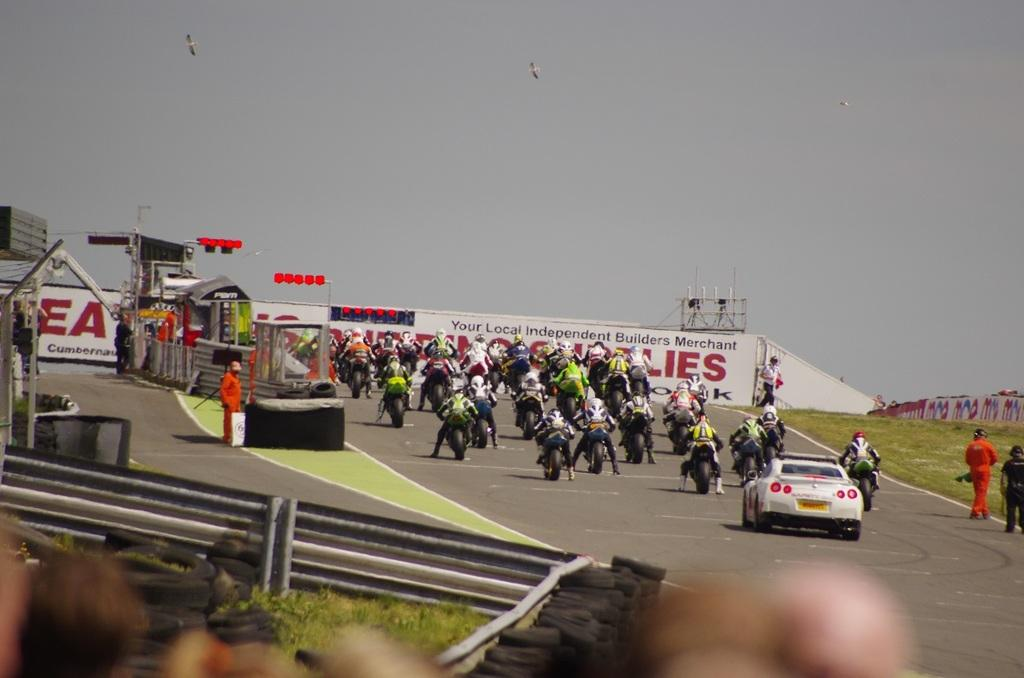<image>
Share a concise interpretation of the image provided. motorcycle racers by a sign reading Your Local Independent Builders Merchant 